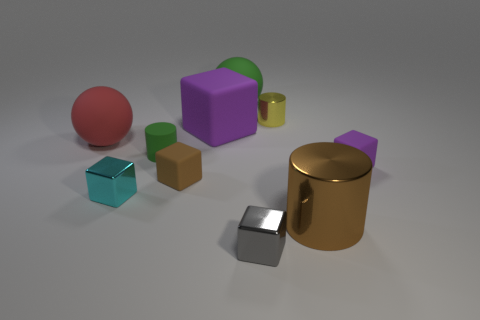Subtract all red spheres. Subtract all purple cylinders. How many spheres are left? 1 Subtract all cyan blocks. How many brown spheres are left? 0 Add 8 browns. How many big things exist? 0 Subtract all tiny metal things. Subtract all large green objects. How many objects are left? 6 Add 6 small brown matte things. How many small brown matte things are left? 7 Add 6 tiny gray objects. How many tiny gray objects exist? 7 Subtract all brown cylinders. How many cylinders are left? 2 Subtract all small cubes. How many cubes are left? 1 Subtract 1 green balls. How many objects are left? 9 Subtract all purple cubes. How many were subtracted if there are1purple cubes left? 1 